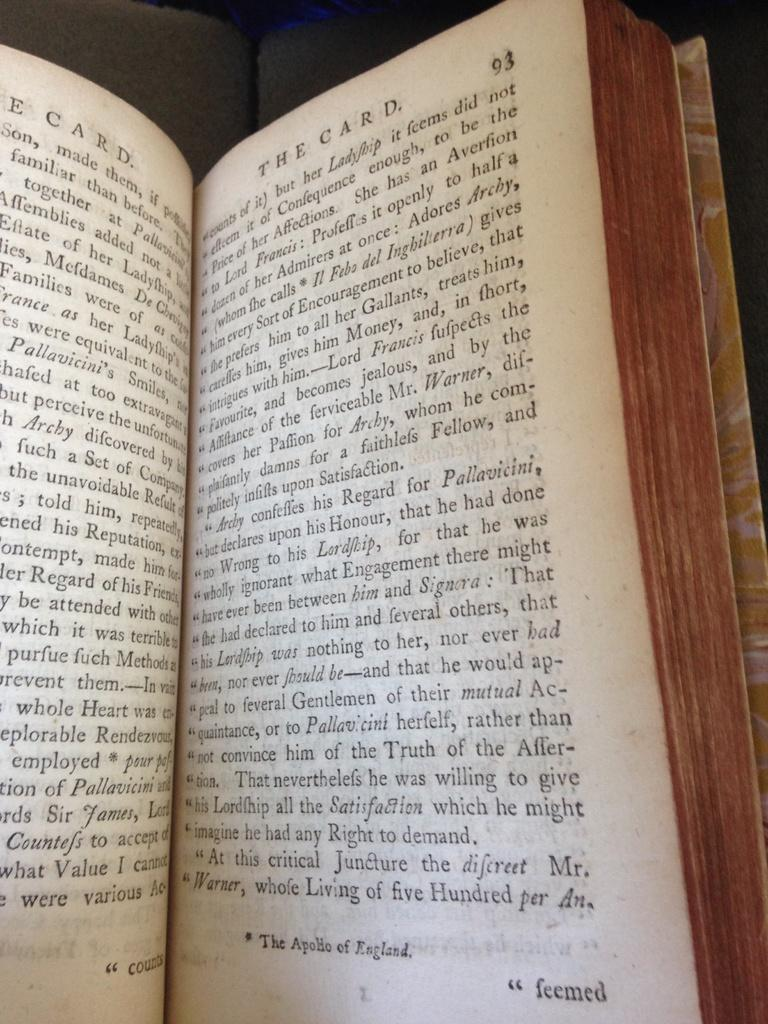<image>
Write a terse but informative summary of the picture. A book called The Card is open to page 93. 